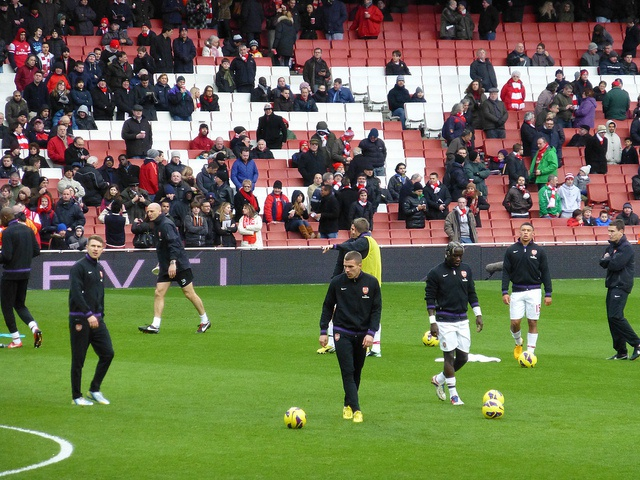Describe the objects in this image and their specific colors. I can see people in black, gray, brown, and white tones, people in black, gray, and olive tones, people in black, white, gray, and olive tones, people in black, lightgray, and tan tones, and people in black, white, and gray tones in this image. 